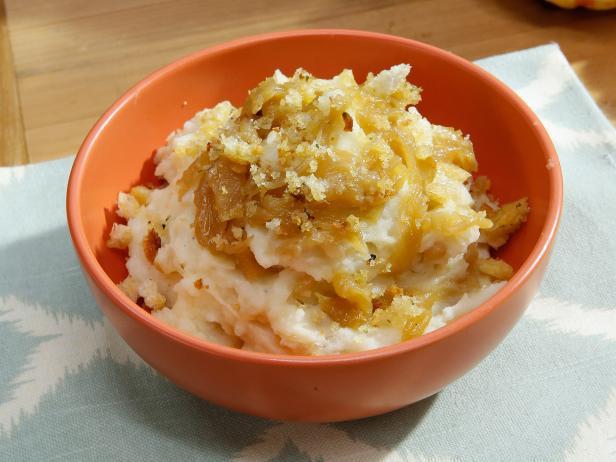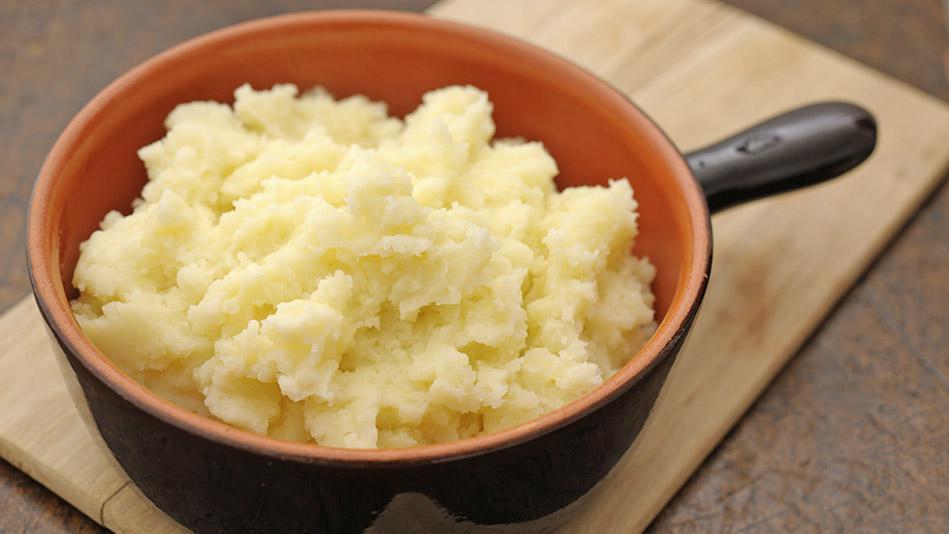The first image is the image on the left, the second image is the image on the right. Examine the images to the left and right. Is the description "There is a utensil sitting in the dish of food in the image on the right." accurate? Answer yes or no. No. The first image is the image on the left, the second image is the image on the right. Evaluate the accuracy of this statement regarding the images: "there is a serving spoon in the disg of potatoes". Is it true? Answer yes or no. No. 